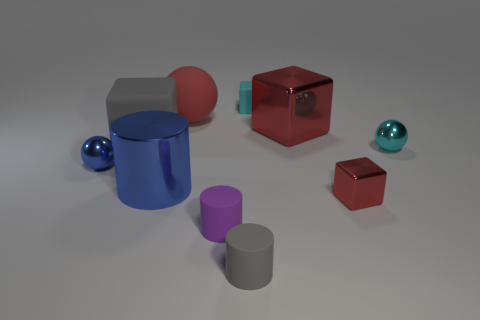Subtract all cylinders. How many objects are left? 7 Subtract all gray shiny balls. Subtract all gray things. How many objects are left? 8 Add 9 small cyan matte blocks. How many small cyan matte blocks are left? 10 Add 3 big gray objects. How many big gray objects exist? 4 Subtract 0 blue blocks. How many objects are left? 10 